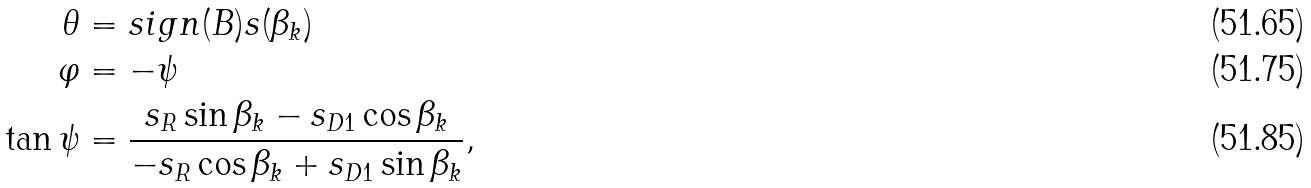Convert formula to latex. <formula><loc_0><loc_0><loc_500><loc_500>\theta & = s i g n ( B ) s ( \beta _ { k } ) \\ \varphi & = - \psi \\ \tan \psi & = \frac { s _ { R } \sin \beta _ { k } - s _ { D 1 } \cos \beta _ { k } } { - s _ { R } \cos \beta _ { k } + s _ { D 1 } \sin \beta _ { k } } ,</formula> 